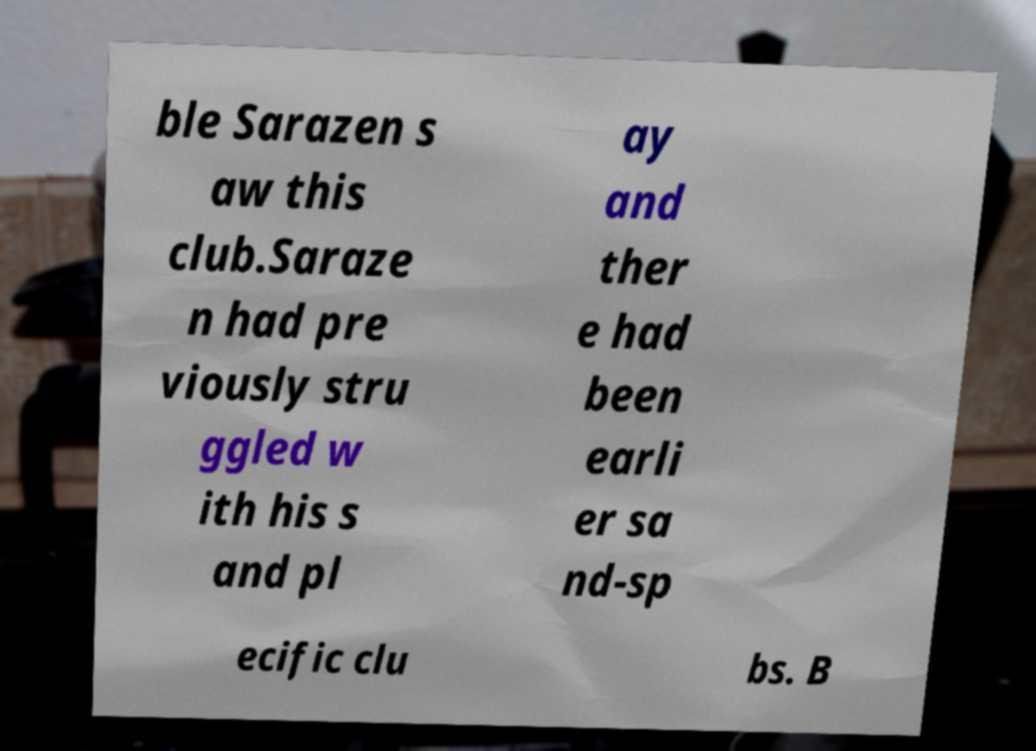There's text embedded in this image that I need extracted. Can you transcribe it verbatim? ble Sarazen s aw this club.Saraze n had pre viously stru ggled w ith his s and pl ay and ther e had been earli er sa nd-sp ecific clu bs. B 